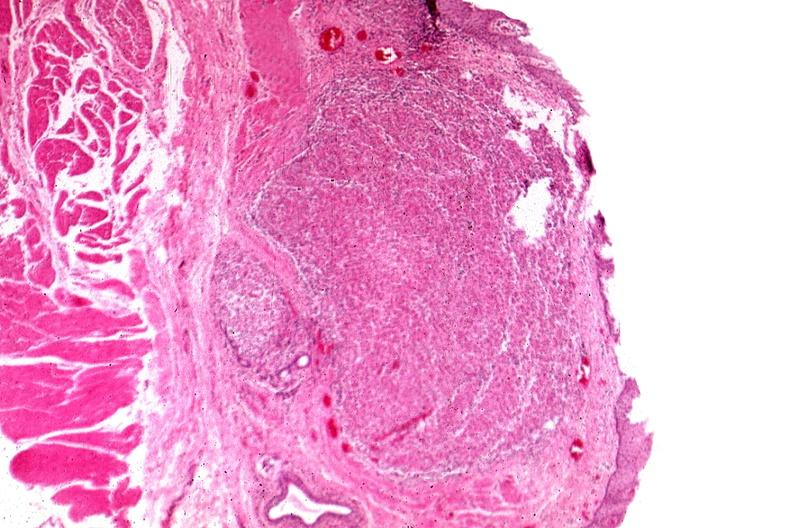what is present?
Answer the question using a single word or phrase. Esophagus 